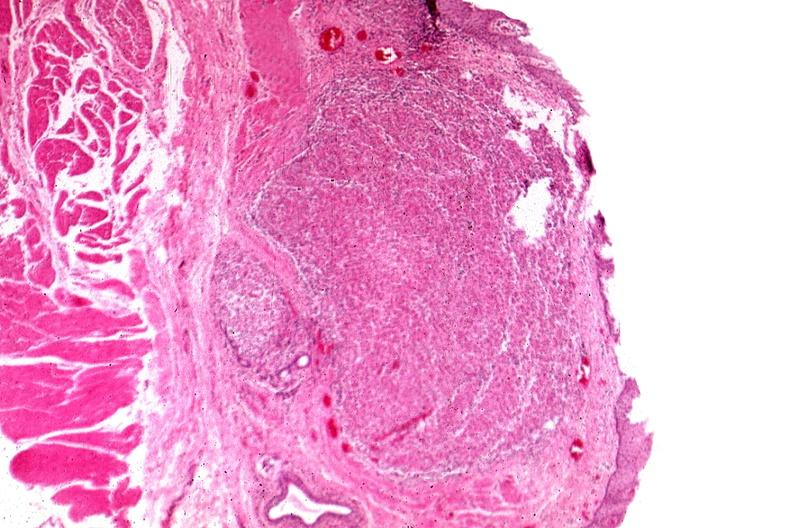what is present?
Answer the question using a single word or phrase. Esophagus 